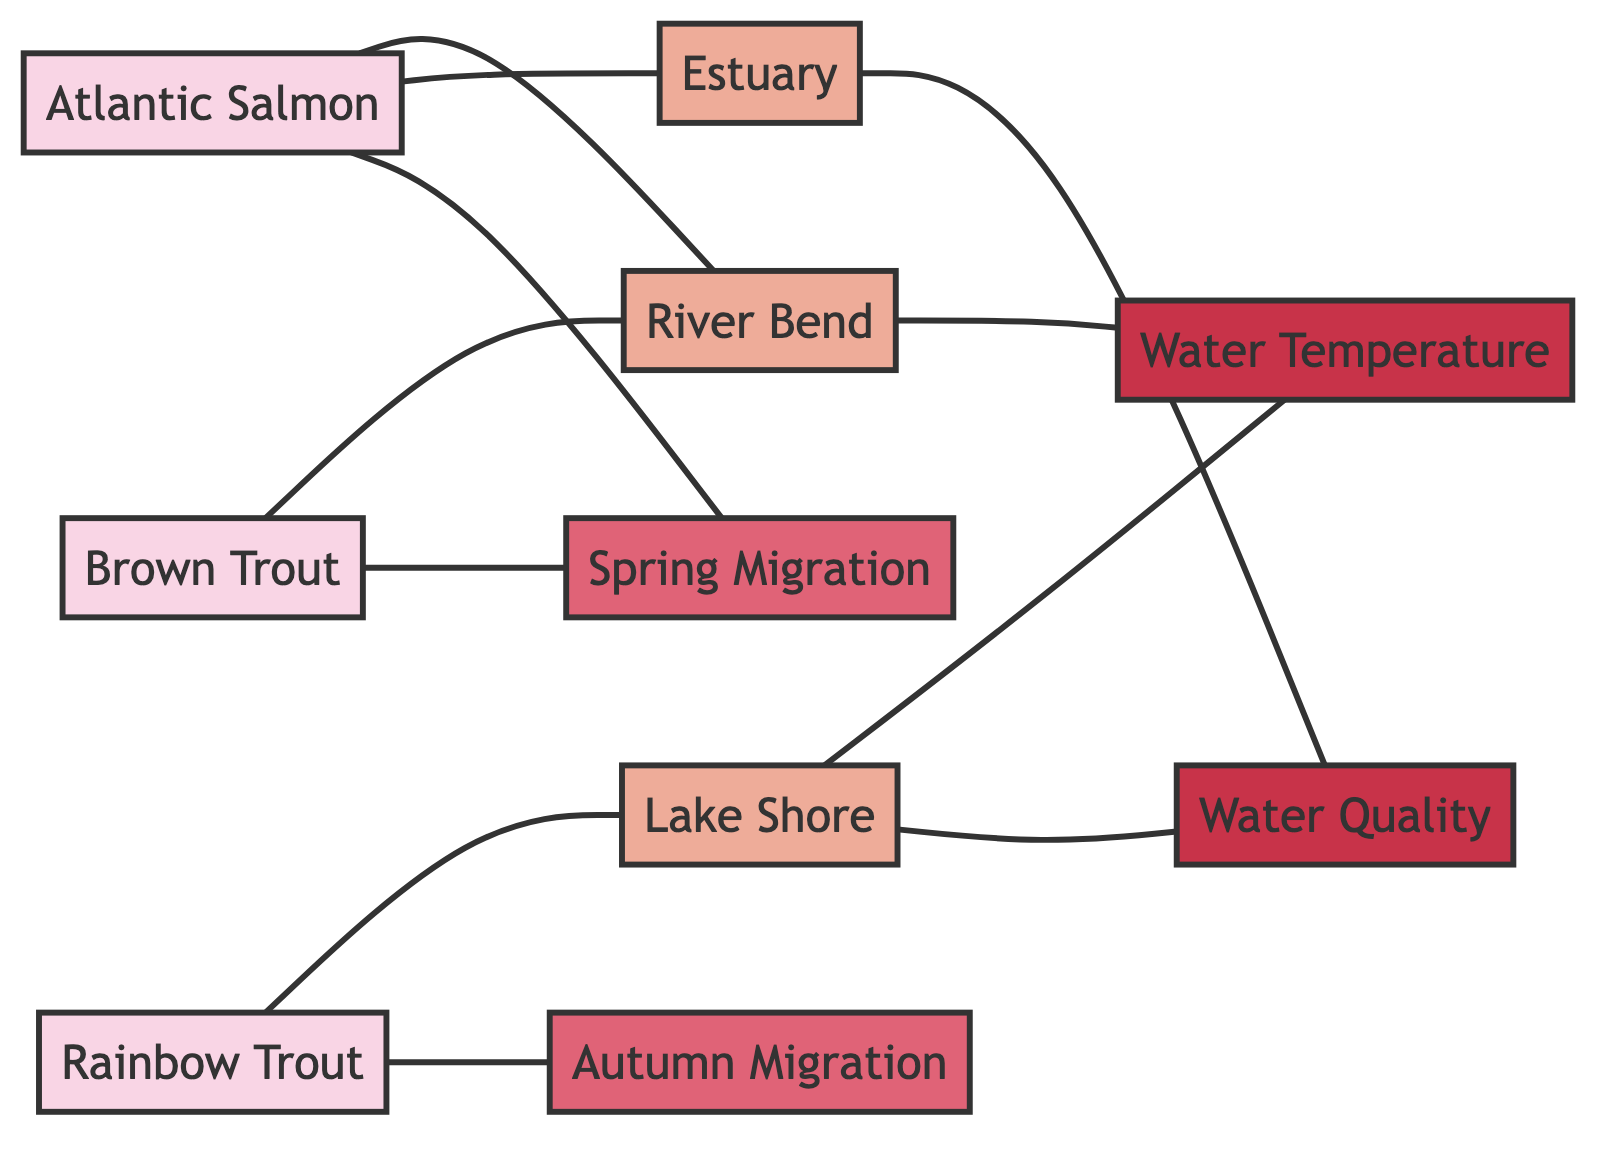What fish species inhabit the River Bend? The diagram shows an edge connecting "Fish Species A" (Atlantic Salmon) and "Fish Species C" (Brown Trout) to "Fishing Area" (River Bend). Thus, both fish species inhabit this area.
Answer: Atlantic Salmon, Brown Trout How many fishing areas are represented in the diagram? The diagram contains three nodes representing fishing areas: River Bend, Estuary, and Lake Shore. Therefore, counting these nodes gives us the total number of fishing areas.
Answer: 3 Which migration pattern is associated with Rainbow Trout? The diagram indicates a connection from "Rainbow Trout" (Fish Species B) to "Autumn Migration" (Migration Pattern). Hence, this is the migration pattern for Rainbow Trout.
Answer: Autumn Migration What environment factor affects Lake Shore? The diagram presents relationships showing that "Water Temperature" and "Water Quality" both affect "Lake Shore." Enumerating these connections provides the answer.
Answer: Water Temperature, Water Quality Which fish species migrates during Spring Migration? The edges linking "Fish Species A" (Atlantic Salmon) and "Fish Species C" (Brown Trout) to "Spring Migration" indicate that both fish species migrate during this time. Thus, the answer includes both species.
Answer: Atlantic Salmon, Brown Trout How many edges connect to the Estuary node? To determine the number of edges connecting to the "Estuary" node, we observe its connections in the diagram. The Estuary has one relationship with Fish Species A and another with "Water Quality." Therefore, counting the edges gives us the total.
Answer: 2 What is the relationship between Lake Shore and Water Quality? The diagram illustrates an edge connection between "Lake Shore" (Fishing Area) and "Water Quality" (Environment Factor), indicating that Lake Shore is affected by Water Quality.
Answer: affected by Which fish species are indicated to migrate in Spring? Analyzing the edges connecting fish species to the "Spring Migration" node, we find that both "Atlantic Salmon" and "Brown Trout" are identified as migrating during this season. Therefore, the answer comprises both species.
Answer: Atlantic Salmon, Brown Trout How many fish species inhabit the identified fishing areas? The diagram shows that three fish species inhabit the fishing areas: "Atlantic Salmon," "Rainbow Trout," and "Brown Trout." Counting these nodes gives us the total number of species in the areas.
Answer: 3 Which environment factor is associated with River Bend? The diagram reveals a connection between "River Bend" (Fishing Area) and "Water Temperature" (Environment Factor), indicating that this environment factor is associated with River Bend.
Answer: Water Temperature 